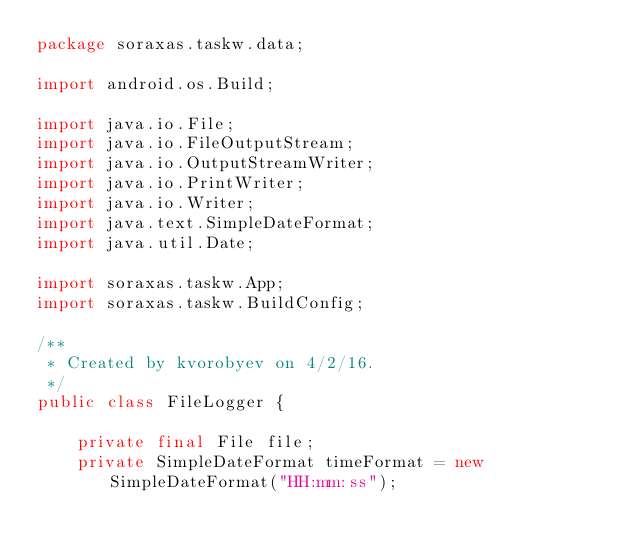<code> <loc_0><loc_0><loc_500><loc_500><_Java_>package soraxas.taskw.data;

import android.os.Build;

import java.io.File;
import java.io.FileOutputStream;
import java.io.OutputStreamWriter;
import java.io.PrintWriter;
import java.io.Writer;
import java.text.SimpleDateFormat;
import java.util.Date;

import soraxas.taskw.App;
import soraxas.taskw.BuildConfig;

/**
 * Created by kvorobyev on 4/2/16.
 */
public class FileLogger {

    private final File file;
    private SimpleDateFormat timeFormat = new SimpleDateFormat("HH:mm:ss");
</code> 